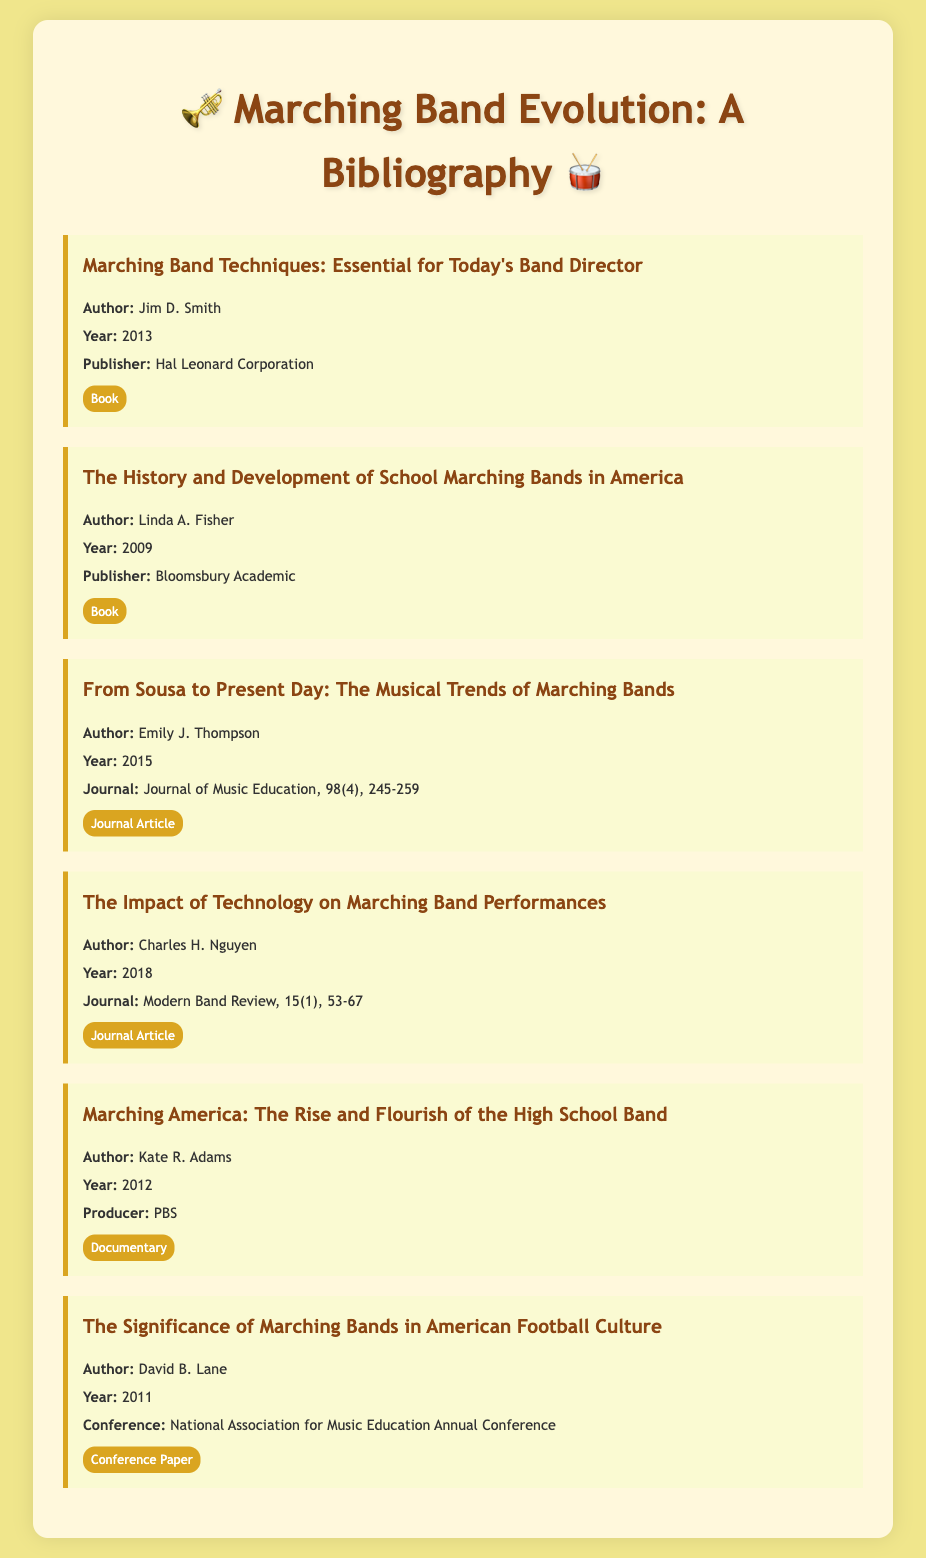What is the title of the first bibliography item? The title of the first item is listed at the top of the section, which is "Marching Band Techniques: Essential for Today's Band Director."
Answer: Marching Band Techniques: Essential for Today's Band Director Who is the author of the book published in 2009? The author's name is identified in the bibliography item for this book as Linda A. Fisher.
Answer: Linda A. Fisher In what year was "From Sousa to Present Day" published? The publication year for this journal article is mentioned directly in the citation, which is 2015.
Answer: 2015 How many journal articles are listed in the bibliography? By counting the specific types tagged in the document, we can see that there are two journal articles included in the bibliography.
Answer: 2 What is the publisher of "Marching America"? The publisher information is provided for the documentary in the bibliography, which is PBS.
Answer: PBS What type of document is "The Impact of Technology on Marching Band Performances"? The category for this item is labeled as a "Journal Article."
Answer: Journal Article What conference was "The Significance of Marching Bands in American Football Culture" presented at? The relevant details specify that this paper was presented at the National Association for Music Education Annual Conference.
Answer: National Association for Music Education Annual Conference 